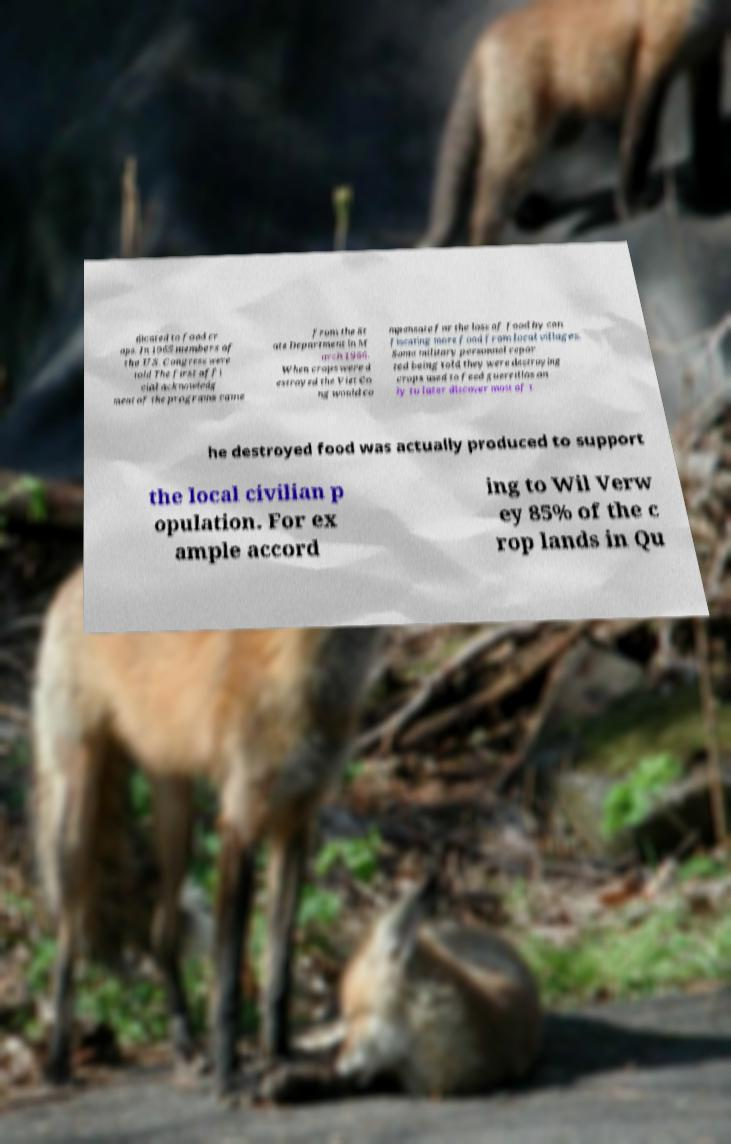Could you assist in decoding the text presented in this image and type it out clearly? dicated to food cr ops. In 1965 members of the U.S. Congress were told The first offi cial acknowledg ment of the programs came from the St ate Department in M arch 1966. When crops were d estroyed the Viet Co ng would co mpensate for the loss of food by con fiscating more food from local villages. Some military personnel repor ted being told they were destroying crops used to feed guerrillas on ly to later discover most of t he destroyed food was actually produced to support the local civilian p opulation. For ex ample accord ing to Wil Verw ey 85% of the c rop lands in Qu 